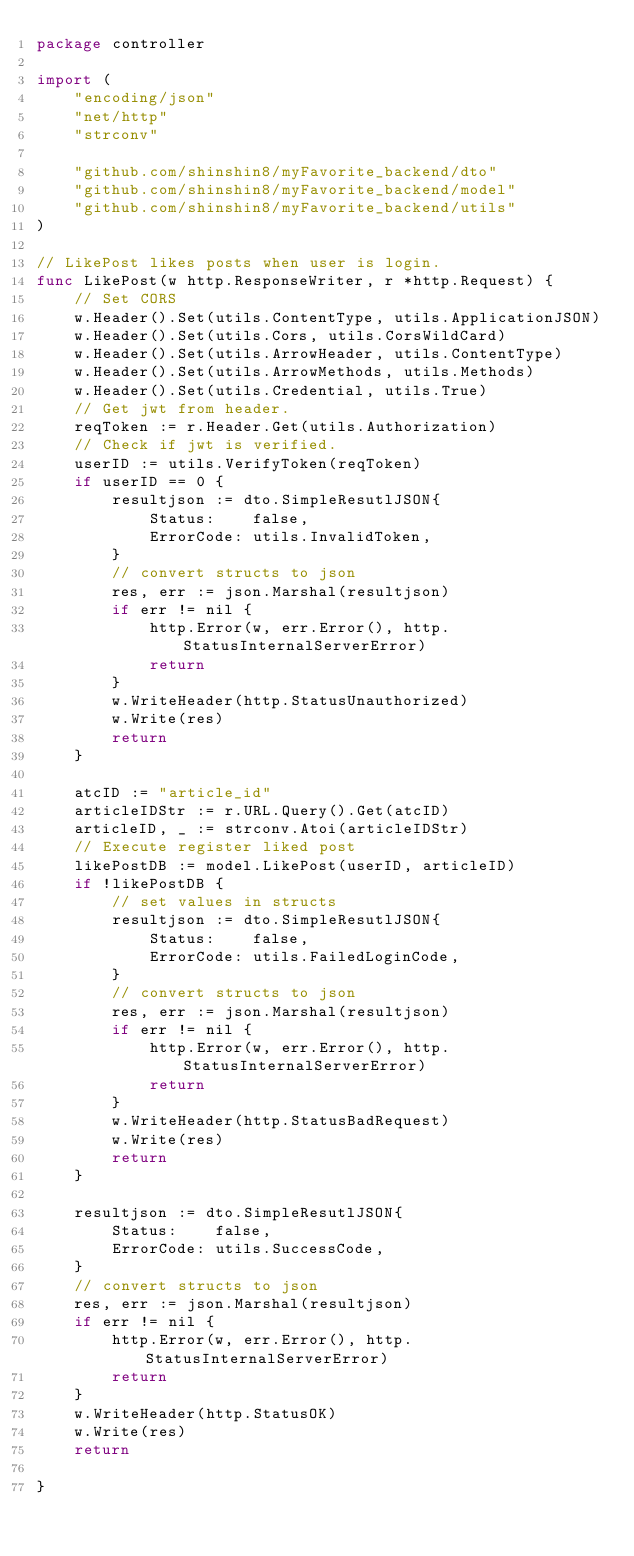<code> <loc_0><loc_0><loc_500><loc_500><_Go_>package controller

import (
	"encoding/json"
	"net/http"
	"strconv"

	"github.com/shinshin8/myFavorite_backend/dto"
	"github.com/shinshin8/myFavorite_backend/model"
	"github.com/shinshin8/myFavorite_backend/utils"
)

// LikePost likes posts when user is login.
func LikePost(w http.ResponseWriter, r *http.Request) {
	// Set CORS
	w.Header().Set(utils.ContentType, utils.ApplicationJSON)
	w.Header().Set(utils.Cors, utils.CorsWildCard)
	w.Header().Set(utils.ArrowHeader, utils.ContentType)
	w.Header().Set(utils.ArrowMethods, utils.Methods)
	w.Header().Set(utils.Credential, utils.True)
	// Get jwt from header.
	reqToken := r.Header.Get(utils.Authorization)
	// Check if jwt is verified.
	userID := utils.VerifyToken(reqToken)
	if userID == 0 {
		resultjson := dto.SimpleResutlJSON{
			Status:    false,
			ErrorCode: utils.InvalidToken,
		}
		// convert structs to json
		res, err := json.Marshal(resultjson)
		if err != nil {
			http.Error(w, err.Error(), http.StatusInternalServerError)
			return
		}
		w.WriteHeader(http.StatusUnauthorized)
		w.Write(res)
		return
	}

	atcID := "article_id"
	articleIDStr := r.URL.Query().Get(atcID)
	articleID, _ := strconv.Atoi(articleIDStr)
	// Execute register liked post
	likePostDB := model.LikePost(userID, articleID)
	if !likePostDB {
		// set values in structs
		resultjson := dto.SimpleResutlJSON{
			Status:    false,
			ErrorCode: utils.FailedLoginCode,
		}
		// convert structs to json
		res, err := json.Marshal(resultjson)
		if err != nil {
			http.Error(w, err.Error(), http.StatusInternalServerError)
			return
		}
		w.WriteHeader(http.StatusBadRequest)
		w.Write(res)
		return
	}

	resultjson := dto.SimpleResutlJSON{
		Status:    false,
		ErrorCode: utils.SuccessCode,
	}
	// convert structs to json
	res, err := json.Marshal(resultjson)
	if err != nil {
		http.Error(w, err.Error(), http.StatusInternalServerError)
		return
	}
	w.WriteHeader(http.StatusOK)
	w.Write(res)
	return

}
</code> 